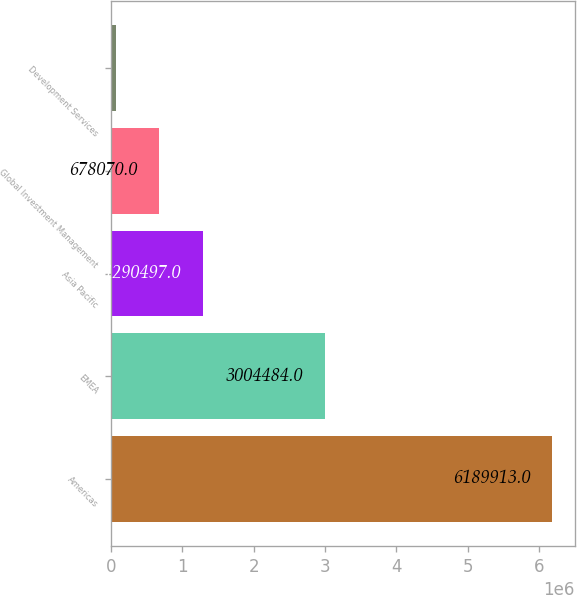Convert chart. <chart><loc_0><loc_0><loc_500><loc_500><bar_chart><fcel>Americas<fcel>EMEA<fcel>Asia Pacific<fcel>Global Investment Management<fcel>Development Services<nl><fcel>6.18991e+06<fcel>3.00448e+06<fcel>1.2905e+06<fcel>678070<fcel>65643<nl></chart> 